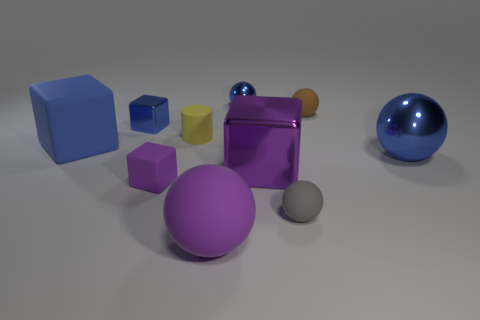Are there any other things that have the same shape as the tiny yellow matte object?
Offer a terse response. No. There is another purple object that is the same shape as the purple metallic thing; what is it made of?
Keep it short and to the point. Rubber. There is a large blue thing on the left side of the small object on the left side of the purple matte block; what is its material?
Provide a short and direct response. Rubber. There is a yellow rubber object; is its shape the same as the matte thing in front of the gray matte object?
Keep it short and to the point. No. How many shiny objects are balls or purple objects?
Your answer should be very brief. 3. There is a tiny object that is on the right side of the small sphere in front of the matte block behind the tiny matte cube; what color is it?
Your response must be concise. Brown. How many other things are there of the same material as the small brown ball?
Your response must be concise. 5. There is a small blue object behind the tiny brown matte thing; is its shape the same as the purple metal thing?
Your response must be concise. No. How many big objects are balls or purple matte balls?
Offer a very short reply. 2. Are there the same number of gray spheres that are on the right side of the gray ball and gray matte things that are right of the small yellow matte cylinder?
Your response must be concise. No. 